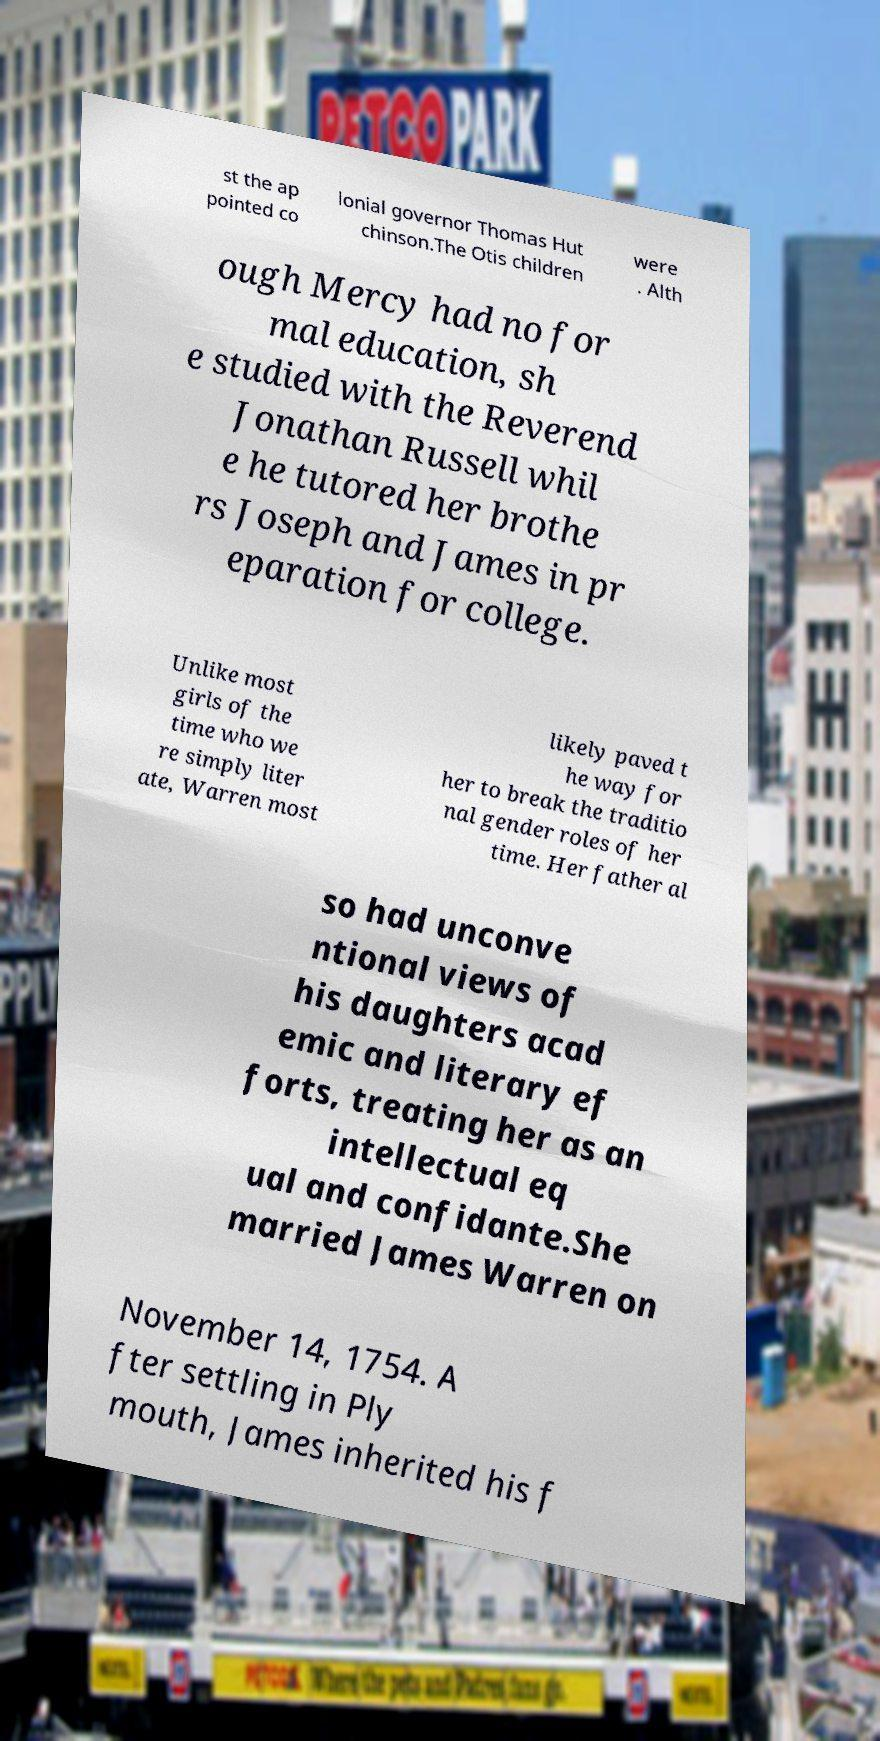Can you read and provide the text displayed in the image?This photo seems to have some interesting text. Can you extract and type it out for me? st the ap pointed co lonial governor Thomas Hut chinson.The Otis children were . Alth ough Mercy had no for mal education, sh e studied with the Reverend Jonathan Russell whil e he tutored her brothe rs Joseph and James in pr eparation for college. Unlike most girls of the time who we re simply liter ate, Warren most likely paved t he way for her to break the traditio nal gender roles of her time. Her father al so had unconve ntional views of his daughters acad emic and literary ef forts, treating her as an intellectual eq ual and confidante.She married James Warren on November 14, 1754. A fter settling in Ply mouth, James inherited his f 